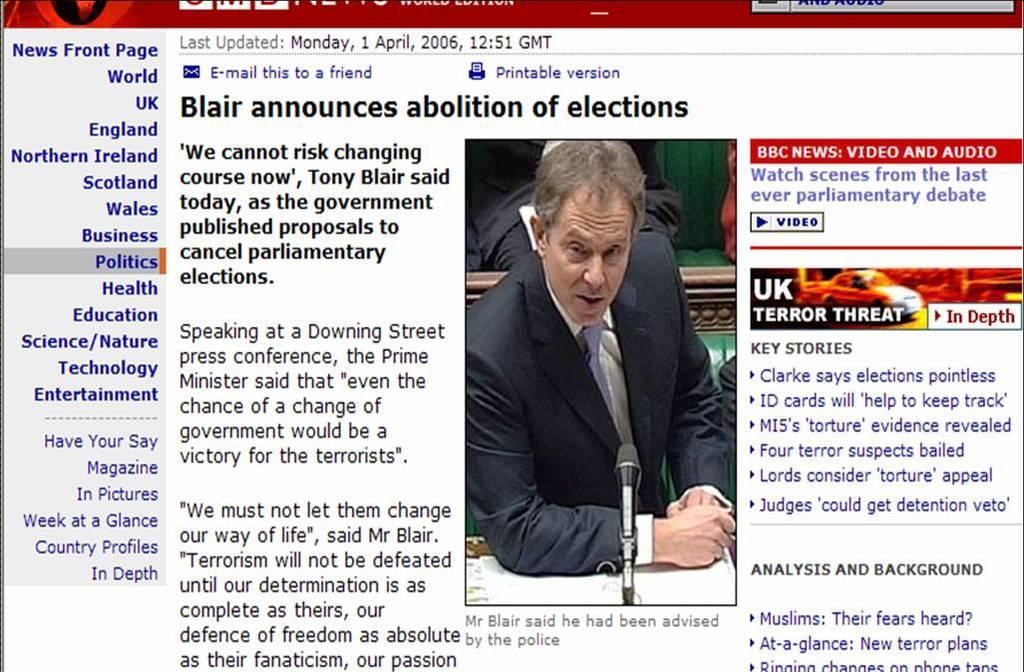How would you summarize this image in a sentence or two? It is a web page with an article on blair announces abolition of election. 